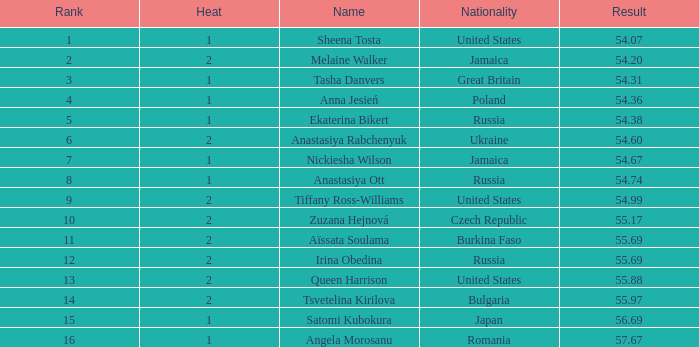What is the rank of tsvetelina kirilova when her result is below 55.97? None. 